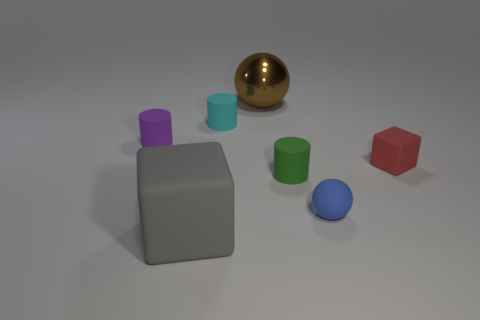Is there anything else that has the same material as the big brown thing?
Offer a very short reply. No. What number of other things are there of the same material as the small blue object
Give a very brief answer. 5. What is the material of the brown object that is the same size as the gray matte object?
Your response must be concise. Metal. Is the shape of the matte thing on the left side of the large cube the same as the small object that is behind the small purple object?
Offer a terse response. Yes. What is the shape of the blue matte object that is the same size as the red block?
Your response must be concise. Sphere. Does the block on the right side of the rubber sphere have the same material as the large object that is right of the gray matte block?
Offer a terse response. No. There is a tiny blue rubber ball that is right of the tiny green thing; is there a small matte object that is to the left of it?
Your response must be concise. Yes. What is the color of the tiny sphere that is made of the same material as the tiny purple object?
Keep it short and to the point. Blue. Are there more large brown metallic balls than blue shiny balls?
Make the answer very short. Yes. What number of objects are either big objects that are behind the matte sphere or metallic objects?
Ensure brevity in your answer.  1. 